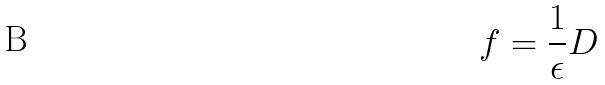Convert formula to latex. <formula><loc_0><loc_0><loc_500><loc_500>f = \frac { 1 } { \epsilon } D</formula> 